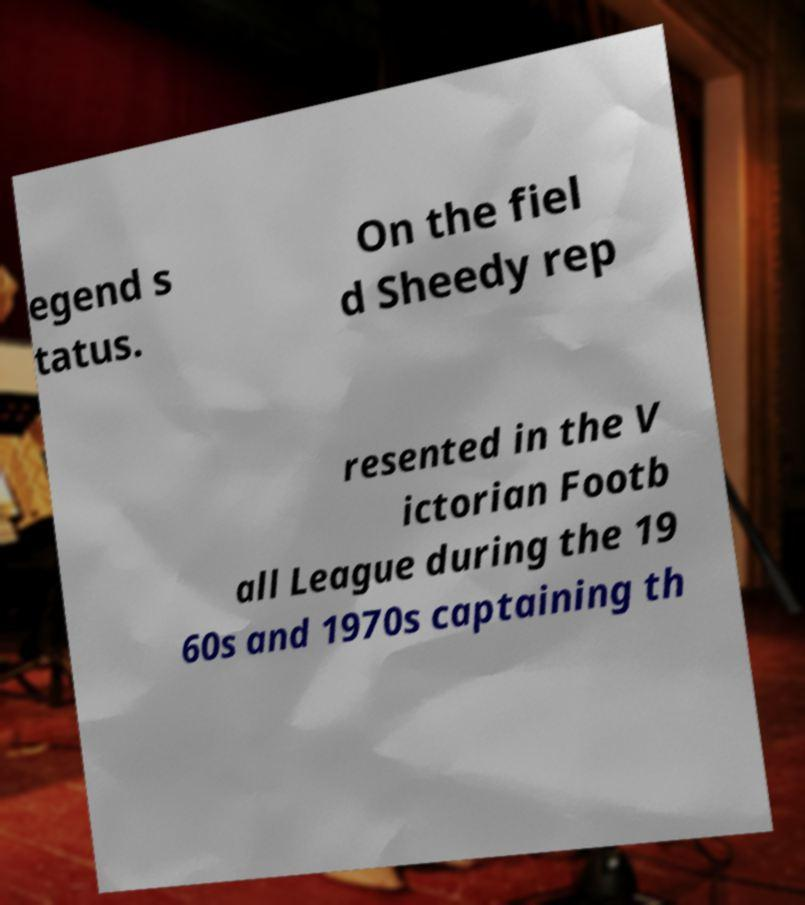Can you accurately transcribe the text from the provided image for me? egend s tatus. On the fiel d Sheedy rep resented in the V ictorian Footb all League during the 19 60s and 1970s captaining th 